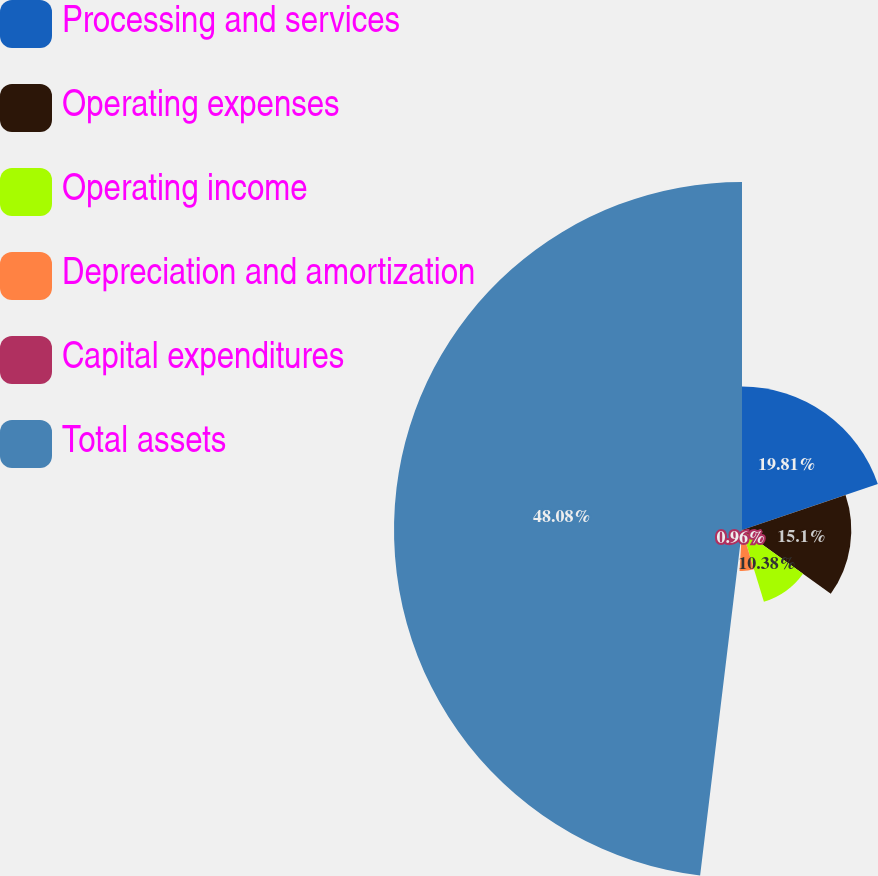Convert chart to OTSL. <chart><loc_0><loc_0><loc_500><loc_500><pie_chart><fcel>Processing and services<fcel>Operating expenses<fcel>Operating income<fcel>Depreciation and amortization<fcel>Capital expenditures<fcel>Total assets<nl><fcel>19.81%<fcel>15.1%<fcel>10.38%<fcel>5.67%<fcel>0.96%<fcel>48.08%<nl></chart> 